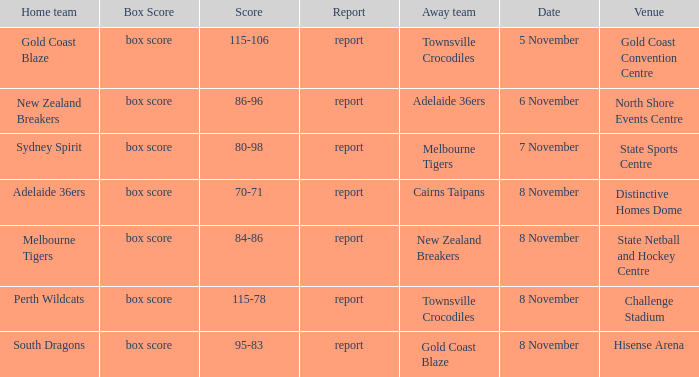What was the box score during a home game of the Adelaide 36ers? Box score. 